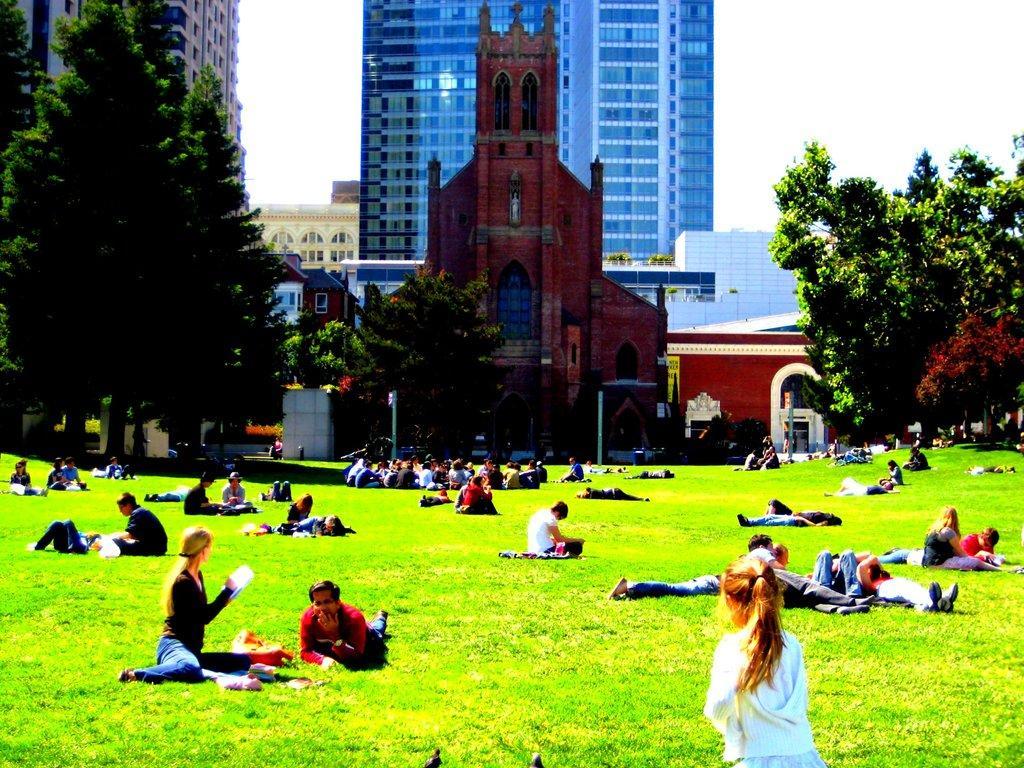Please provide a concise description of this image. In the background we can see the buildings,windows, trees and the church. In this picture we can see the boards, poles. We can see the people. Few are sitting and few are resting on the green grass. At the bottom portion of the picture we can see a girl. We can see a woman and she is holding a book, staring at the church. 